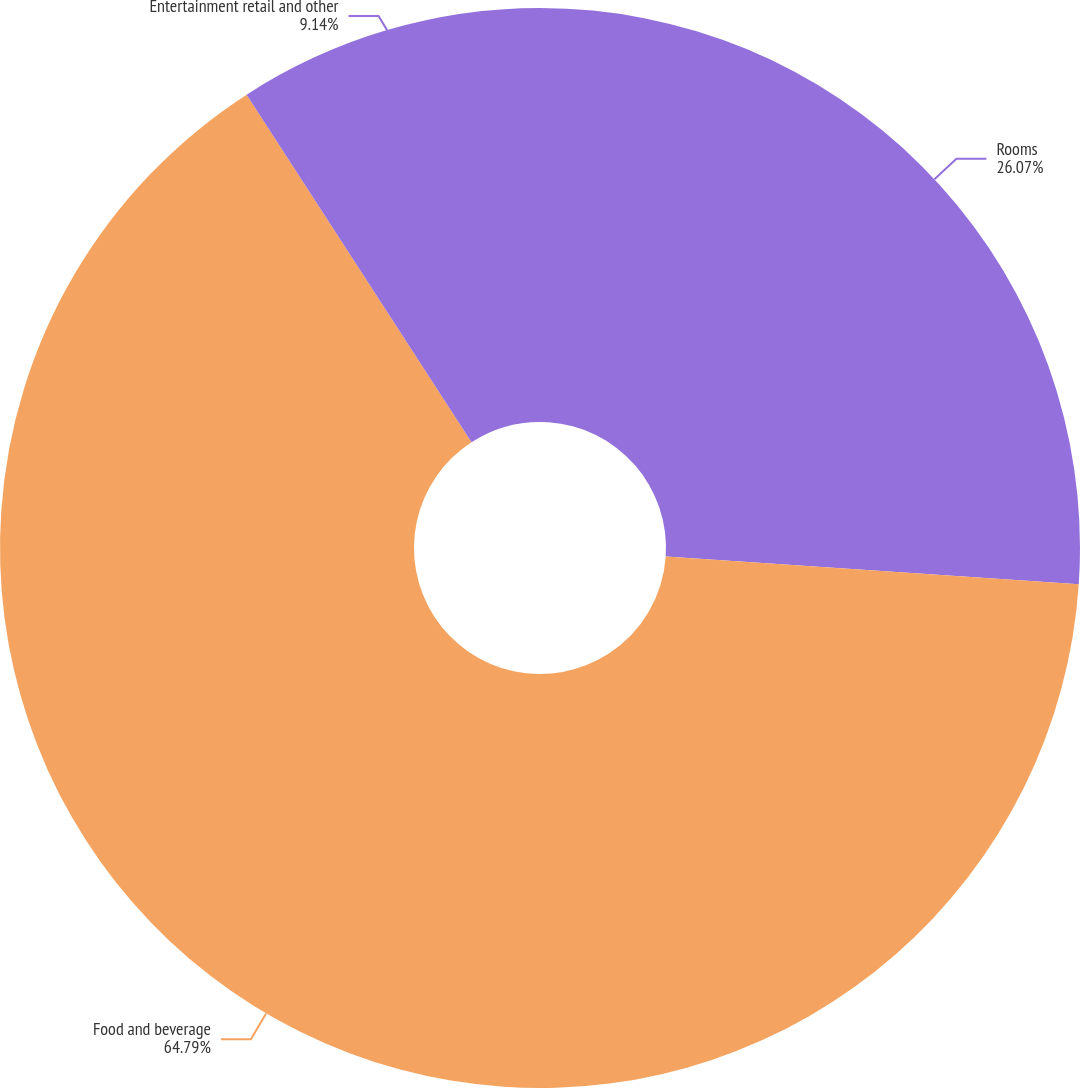Convert chart. <chart><loc_0><loc_0><loc_500><loc_500><pie_chart><fcel>Rooms<fcel>Food and beverage<fcel>Entertainment retail and other<nl><fcel>26.07%<fcel>64.78%<fcel>9.14%<nl></chart> 